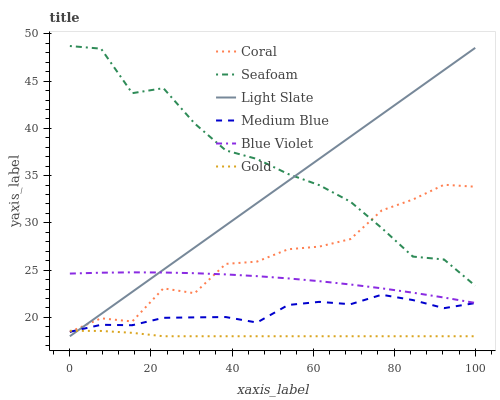Does Light Slate have the minimum area under the curve?
Answer yes or no. No. Does Light Slate have the maximum area under the curve?
Answer yes or no. No. Is Coral the smoothest?
Answer yes or no. No. Is Light Slate the roughest?
Answer yes or no. No. Does Coral have the lowest value?
Answer yes or no. No. Does Light Slate have the highest value?
Answer yes or no. No. Is Gold less than Seafoam?
Answer yes or no. Yes. Is Blue Violet greater than Medium Blue?
Answer yes or no. Yes. Does Gold intersect Seafoam?
Answer yes or no. No. 